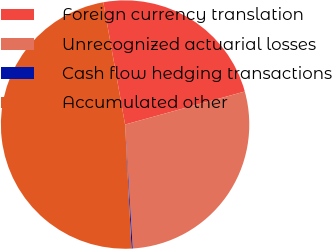<chart> <loc_0><loc_0><loc_500><loc_500><pie_chart><fcel>Foreign currency translation<fcel>Unrecognized actuarial losses<fcel>Cash flow hedging transactions<fcel>Accumulated other<nl><fcel>23.52%<fcel>28.3%<fcel>0.16%<fcel>48.02%<nl></chart> 